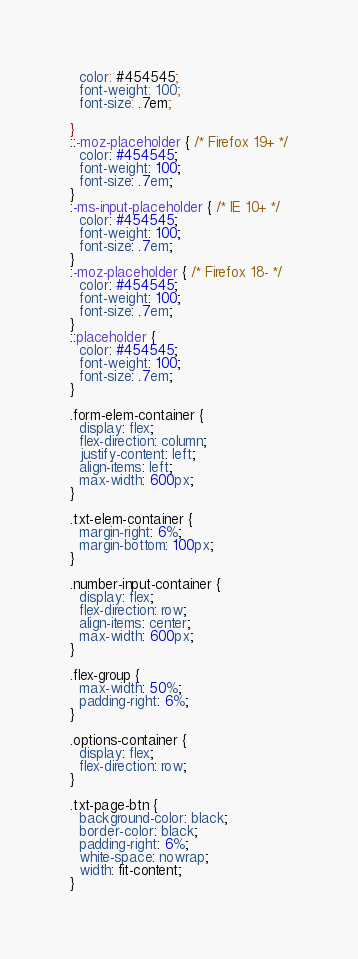Convert code to text. <code><loc_0><loc_0><loc_500><loc_500><_CSS_>  color: #454545;
  font-weight: 100;
  font-size: .7em;

}
::-moz-placeholder { /* Firefox 19+ */
  color: #454545;
  font-weight: 100;
  font-size: .7em;
}
:-ms-input-placeholder { /* IE 10+ */
  color: #454545;
  font-weight: 100;
  font-size: .7em;
}
:-moz-placeholder { /* Firefox 18- */
  color: #454545;
  font-weight: 100;
  font-size: .7em;
}
::placeholder {
  color: #454545;
  font-weight: 100;
  font-size: .7em;
}

.form-elem-container {
  display: flex;
  flex-direction: column;
  justify-content: left;
  align-items: left;
  max-width: 600px;
}

.txt-elem-container {
  margin-right: 6%;
  margin-bottom: 100px;
}

.number-input-container {
  display: flex;
  flex-direction: row;
  align-items: center;
  max-width: 600px;
}

.flex-group {
  max-width: 50%;
  padding-right: 6%;
}

.options-container {
  display: flex;
  flex-direction: row;
}

.txt-page-btn {
  background-color: black;
  border-color: black;
  padding-right: 6%;
  white-space: nowrap;
  width: fit-content;
}
</code> 